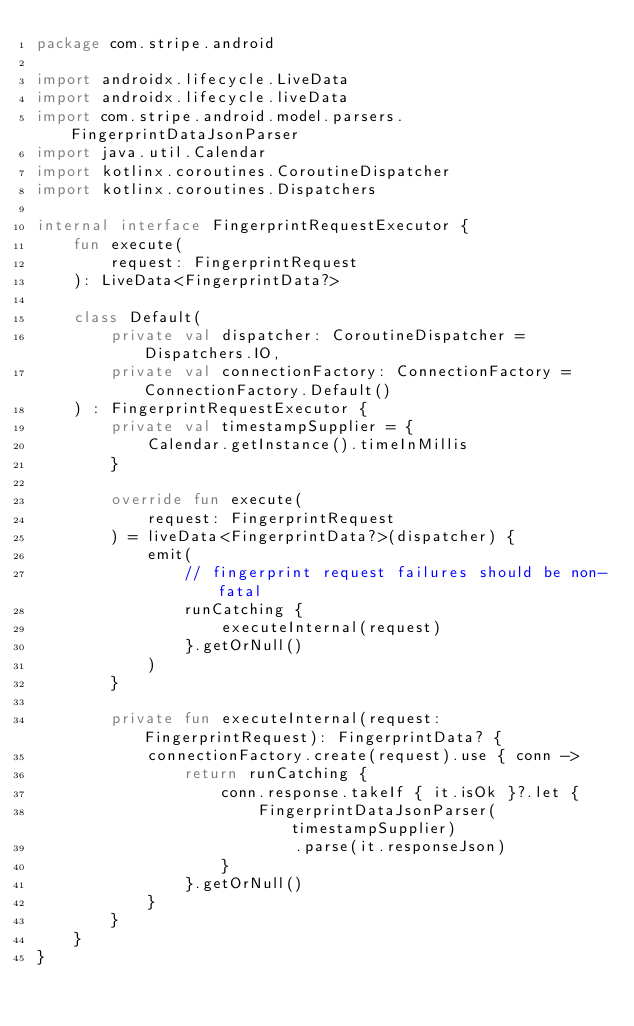<code> <loc_0><loc_0><loc_500><loc_500><_Kotlin_>package com.stripe.android

import androidx.lifecycle.LiveData
import androidx.lifecycle.liveData
import com.stripe.android.model.parsers.FingerprintDataJsonParser
import java.util.Calendar
import kotlinx.coroutines.CoroutineDispatcher
import kotlinx.coroutines.Dispatchers

internal interface FingerprintRequestExecutor {
    fun execute(
        request: FingerprintRequest
    ): LiveData<FingerprintData?>

    class Default(
        private val dispatcher: CoroutineDispatcher = Dispatchers.IO,
        private val connectionFactory: ConnectionFactory = ConnectionFactory.Default()
    ) : FingerprintRequestExecutor {
        private val timestampSupplier = {
            Calendar.getInstance().timeInMillis
        }

        override fun execute(
            request: FingerprintRequest
        ) = liveData<FingerprintData?>(dispatcher) {
            emit(
                // fingerprint request failures should be non-fatal
                runCatching {
                    executeInternal(request)
                }.getOrNull()
            )
        }

        private fun executeInternal(request: FingerprintRequest): FingerprintData? {
            connectionFactory.create(request).use { conn ->
                return runCatching {
                    conn.response.takeIf { it.isOk }?.let {
                        FingerprintDataJsonParser(timestampSupplier)
                            .parse(it.responseJson)
                    }
                }.getOrNull()
            }
        }
    }
}
</code> 